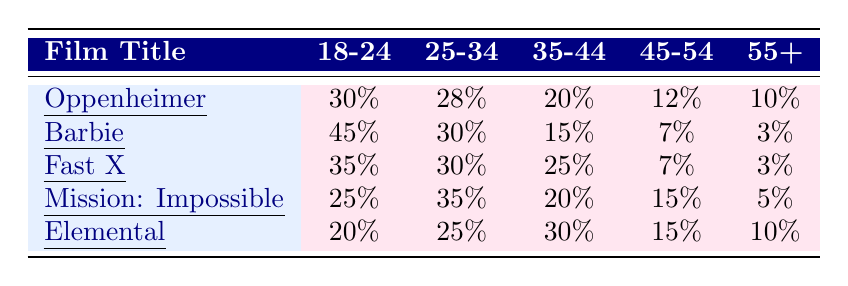What percentage of the audience for "Barbie" is aged 18-24? The table shows that for "Barbie," 45% of the audience falls within the 18-24 age group.
Answer: 45% Which film has the highest percentage of its audience in the 25-34 age group? By comparing the values in the 25-34 column, "Mission: Impossible - Dead Reckoning Part One" has the highest percentage at 35%.
Answer: Mission: Impossible - Dead Reckoning Part One What is the average percentage of the audience aged 55+ across all films listed? The percentages for the 55+ age group are 10%, 3%, 3%, 5%, and 10%. Summing these gives 31%, and dividing by 5 films yields an average of 6.2%.
Answer: 6.2% Is the percentage of Male audience for "Fast X" higher than that for "Barbie"? "Fast X" has 60% Male audience, while "Barbie" has 25%. Since 60% is greater than 25%, the statement is true.
Answer: Yes Which film has a higher average rating: "Elemental" or "Fast X"? "Elemental" has an average rating of 7.0 and "Fast X" has an average rating of 6.5. Since 7.0 is greater than 6.5, "Elemental" has a higher average rating.
Answer: Elemental What is the total percentage of the audience in the 35-44 age group across all films? Adding the percentages for the 35-44 age group, we have 20% (Oppenheimer) + 15% (Barbie) + 25% (Fast X) + 20% (Mission: Impossible) + 30% (Elemental) = 110%.
Answer: 110% Are there more Female viewers for "Oppenheimer" than for "Elemental"? "Oppenheimer" has 40% Female viewers, while "Elemental" has 55%. Since 40% is less than 55%, the answer is no.
Answer: No Which age group is the least represented among the audience for "Mission: Impossible - Dead Reckoning Part One"? Looking at the age groups, the 55+ age group, with only 5%, is the lowest representation for "Mission: Impossible - Dead Reckoning Part One."
Answer: 55+ How does the percentage of Hispanic audience in "Barbie" compare to that in "Fast X"? "Barbie" has 25% Hispanic audience while "Fast X" has 30%. Since 25% is less than 30%, the percentage in "Barbie" is lower.
Answer: Lower Which film has the most balanced gender distribution among its audience? "Barbie" has 25% Male, 70% Female, and 5% Non-binary. While there is a majority of Female viewers, "Elemental" has 40% Male and 55% Female, showing a more balanced distribution.
Answer: Elemental 